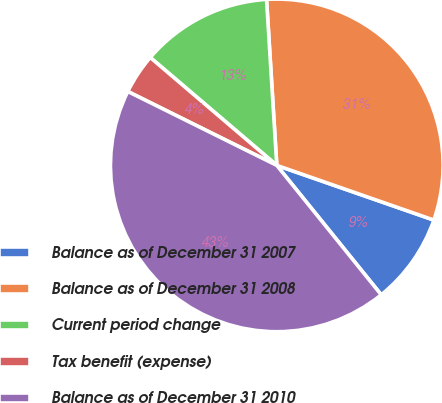<chart> <loc_0><loc_0><loc_500><loc_500><pie_chart><fcel>Balance as of December 31 2007<fcel>Balance as of December 31 2008<fcel>Current period change<fcel>Tax benefit (expense)<fcel>Balance as of December 31 2010<nl><fcel>8.86%<fcel>31.31%<fcel>12.78%<fcel>3.91%<fcel>43.13%<nl></chart> 